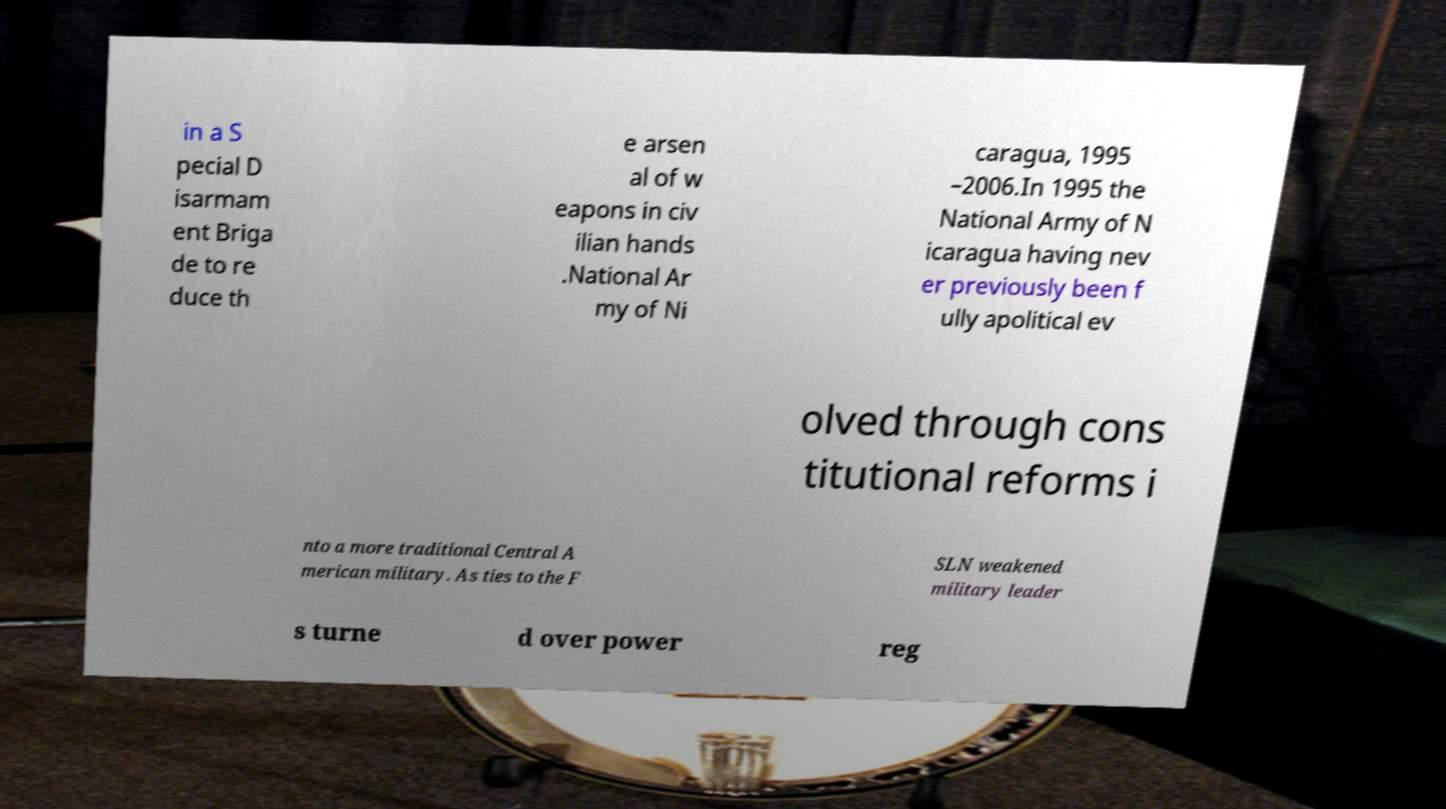What messages or text are displayed in this image? I need them in a readable, typed format. in a S pecial D isarmam ent Briga de to re duce th e arsen al of w eapons in civ ilian hands .National Ar my of Ni caragua, 1995 –2006.In 1995 the National Army of N icaragua having nev er previously been f ully apolitical ev olved through cons titutional reforms i nto a more traditional Central A merican military. As ties to the F SLN weakened military leader s turne d over power reg 